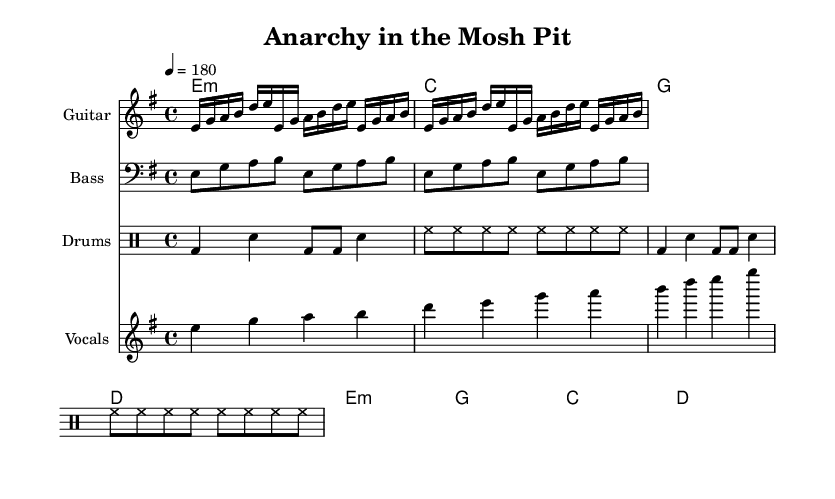What is the key signature of this music? The key signature is E minor, which has one sharp (F#) and aligns with the purpose of this punk song, often utilizing minor keys for a darker tone.
Answer: E minor What is the time signature of this piece? The time signature is 4/4, which is a common time signature in rock music, allowing for a strong and steady rhythm that supports the energetic nature of punk rock.
Answer: 4/4 What is the tempo marking of the piece? The tempo marking is 180 beats per minute, indicating a fast pace typical for punk rock, creating an intense and lively atmosphere.
Answer: 180 How many measures are in the guitar riff section? The guitar riff is repeated twice, indicating there are 8 measures total since each repeat consists of 4 measures, contributing to the driving force of the music.
Answer: 8 What is the main lyrical theme expressed in the chorus? The chorus expresses a rebellious sentiment, highlighting the anti-establishment message typical of punk rock, where the lyrics declare a powerful stance against authority.
Answer: Anarchy What are the primary chords used in the chorus? The primary chords in the chorus are E minor, G, C, and D, which are common chords in punk rock, creating a progression that drives the emotion of rebellion.
Answer: E minor, G, C, D How does the drum pattern contribute to the song's energy? The drum pattern combines bass and snare hits in a driving rhythm with consistent hi-hat cycling, adding to the song’s intensity and supporting the fast-paced style of punk rock music.
Answer: Driving rhythm 